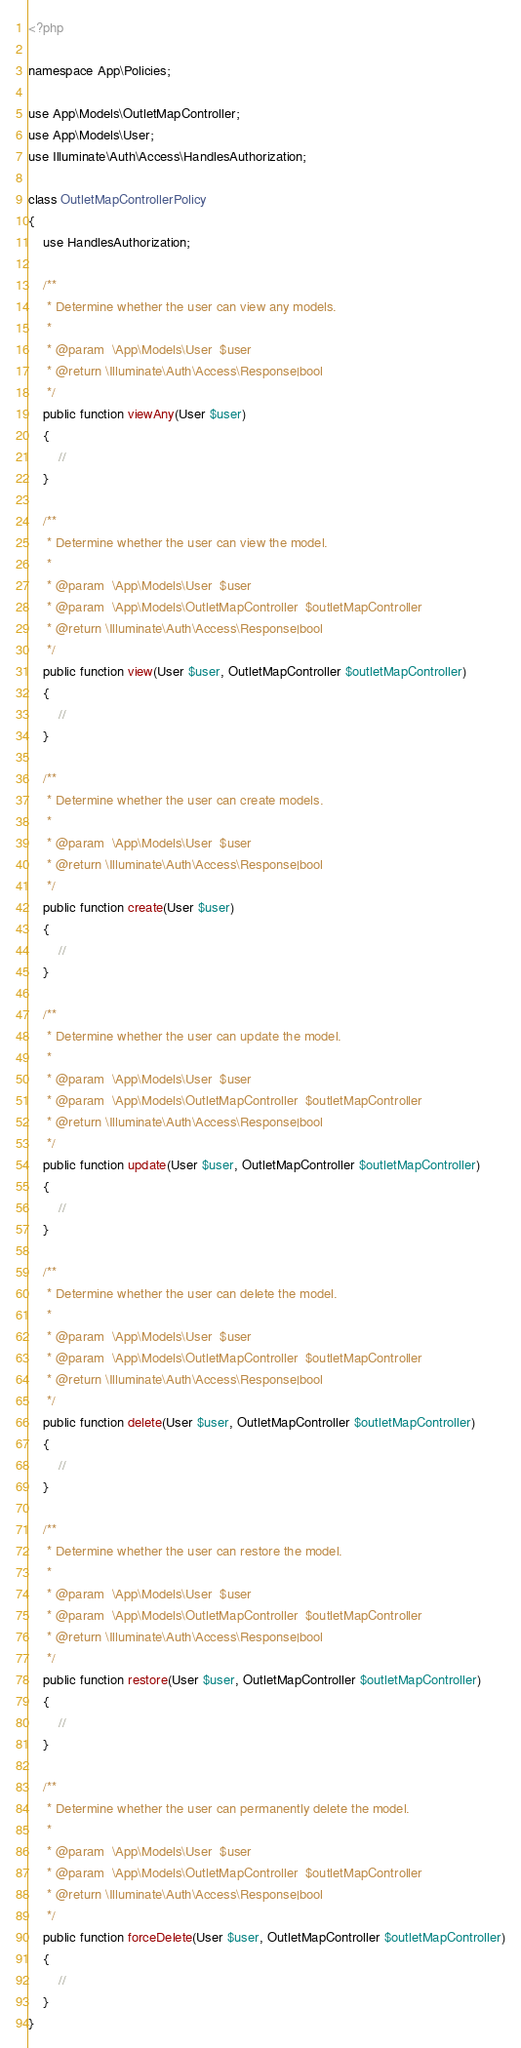<code> <loc_0><loc_0><loc_500><loc_500><_PHP_><?php

namespace App\Policies;

use App\Models\OutletMapController;
use App\Models\User;
use Illuminate\Auth\Access\HandlesAuthorization;

class OutletMapControllerPolicy
{
    use HandlesAuthorization;

    /**
     * Determine whether the user can view any models.
     *
     * @param  \App\Models\User  $user
     * @return \Illuminate\Auth\Access\Response|bool
     */
    public function viewAny(User $user)
    {
        //
    }

    /**
     * Determine whether the user can view the model.
     *
     * @param  \App\Models\User  $user
     * @param  \App\Models\OutletMapController  $outletMapController
     * @return \Illuminate\Auth\Access\Response|bool
     */
    public function view(User $user, OutletMapController $outletMapController)
    {
        //
    }

    /**
     * Determine whether the user can create models.
     *
     * @param  \App\Models\User  $user
     * @return \Illuminate\Auth\Access\Response|bool
     */
    public function create(User $user)
    {
        //
    }

    /**
     * Determine whether the user can update the model.
     *
     * @param  \App\Models\User  $user
     * @param  \App\Models\OutletMapController  $outletMapController
     * @return \Illuminate\Auth\Access\Response|bool
     */
    public function update(User $user, OutletMapController $outletMapController)
    {
        //
    }

    /**
     * Determine whether the user can delete the model.
     *
     * @param  \App\Models\User  $user
     * @param  \App\Models\OutletMapController  $outletMapController
     * @return \Illuminate\Auth\Access\Response|bool
     */
    public function delete(User $user, OutletMapController $outletMapController)
    {
        //
    }

    /**
     * Determine whether the user can restore the model.
     *
     * @param  \App\Models\User  $user
     * @param  \App\Models\OutletMapController  $outletMapController
     * @return \Illuminate\Auth\Access\Response|bool
     */
    public function restore(User $user, OutletMapController $outletMapController)
    {
        //
    }

    /**
     * Determine whether the user can permanently delete the model.
     *
     * @param  \App\Models\User  $user
     * @param  \App\Models\OutletMapController  $outletMapController
     * @return \Illuminate\Auth\Access\Response|bool
     */
    public function forceDelete(User $user, OutletMapController $outletMapController)
    {
        //
    }
}
</code> 